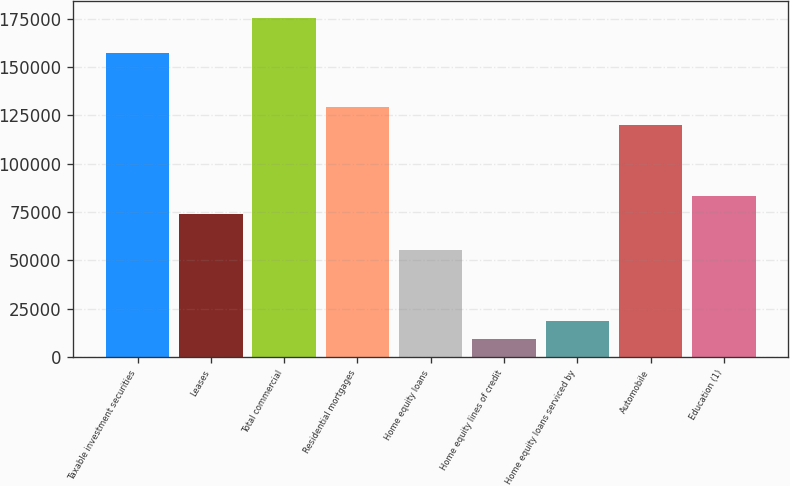Convert chart to OTSL. <chart><loc_0><loc_0><loc_500><loc_500><bar_chart><fcel>Taxable investment securities<fcel>Leases<fcel>Total commercial<fcel>Residential mortgages<fcel>Home equity loans<fcel>Home equity lines of credit<fcel>Home equity loans serviced by<fcel>Automobile<fcel>Education (1)<nl><fcel>157048<fcel>73979.4<fcel>175507<fcel>129358<fcel>55519.8<fcel>9370.8<fcel>18600.6<fcel>120128<fcel>83209.2<nl></chart> 